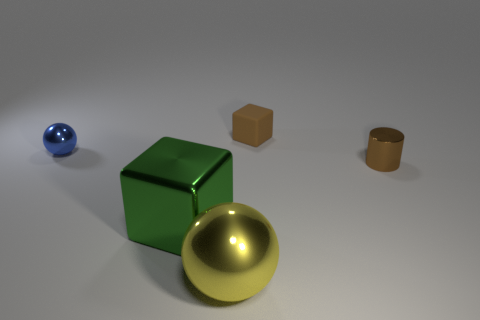Is the number of brown things to the right of the blue sphere greater than the number of brown cubes that are behind the large green metallic block?
Your response must be concise. Yes. There is a rubber cube that is the same color as the tiny metallic cylinder; what is its size?
Provide a succinct answer. Small. The big metal sphere has what color?
Your answer should be compact. Yellow. There is a object that is left of the brown matte cube and on the right side of the big green shiny object; what color is it?
Ensure brevity in your answer.  Yellow. The ball that is in front of the large metallic object that is behind the large yellow ball that is to the right of the tiny blue metallic sphere is what color?
Your answer should be compact. Yellow. There is a metal ball that is the same size as the brown rubber object; what color is it?
Provide a succinct answer. Blue. What shape is the small shiny thing that is on the left side of the small thing right of the tiny brown object that is on the left side of the tiny shiny cylinder?
Provide a succinct answer. Sphere. The tiny object that is the same color as the small cylinder is what shape?
Your answer should be compact. Cube. What number of objects are either small brown cylinders or shiny balls that are on the left side of the yellow thing?
Your answer should be very brief. 2. There is a metal thing that is on the right side of the brown cube; does it have the same size as the brown block?
Keep it short and to the point. Yes. 